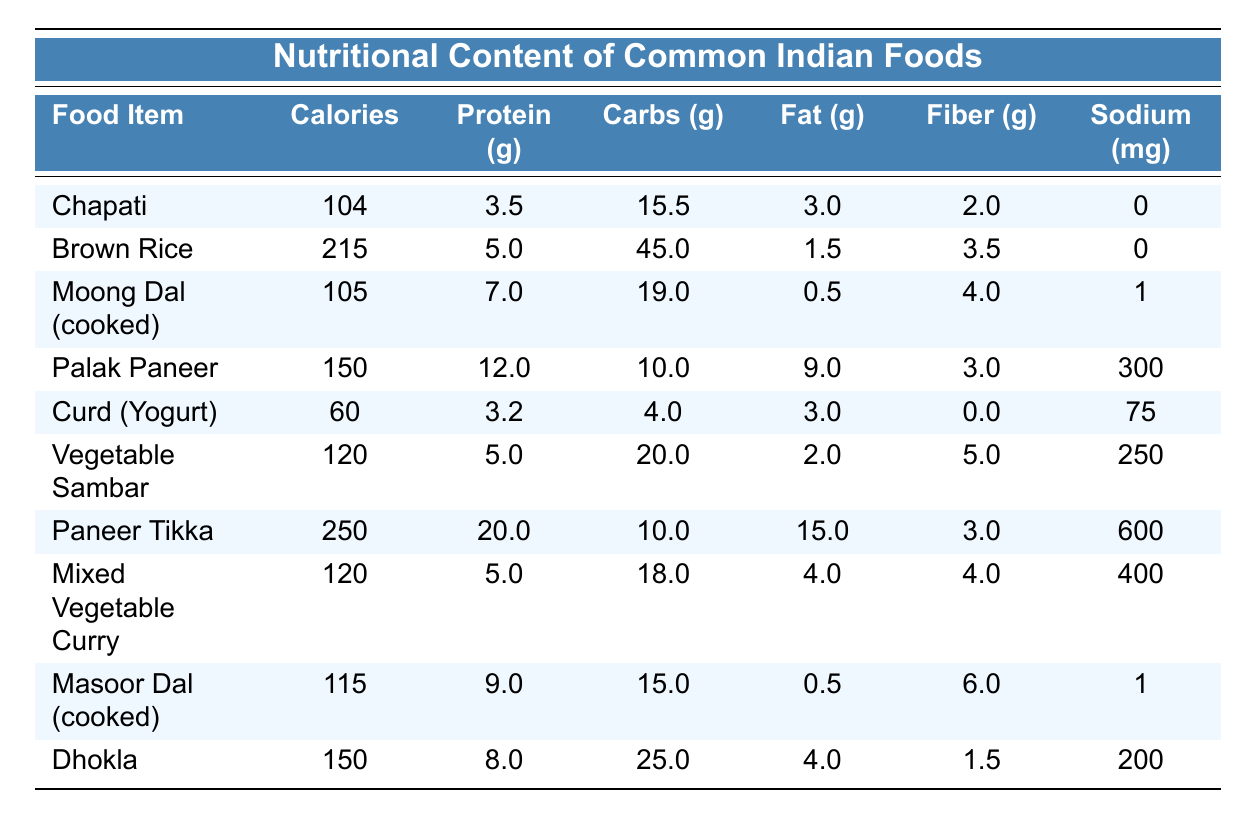What is the calorie content of Palak Paneer? The calorie content for Palak Paneer is mentioned in the table, specifically in the "Calories" column next to the food item. It shows that Palak Paneer has 150 calories.
Answer: 150 Which food item has the highest protein content? Looking at the "Protein (g)" column, the highest value is for Paneer Tikka, which has 20.0 grams of protein, compared to all other items listed.
Answer: Paneer Tikka Is the sodium content in Curd (Yogurt) more than that in Chapati? To answer this, we can compare the sodium content of both food items from the "Sodium (mg)" column. Curd (Yogurt) has 75 mg of sodium, while Chapati has 0 mg. Since 75 mg is greater than 0 mg, the statement is true.
Answer: Yes What is the total calorie content of Moong Dal and Masoor Dal combined? We need to add the calorie values of Moong Dal and Masoor Dal. Moong Dal has 105 calories, and Masoor Dal has 115 calories. Adding them together: 105 + 115 = 220.
Answer: 220 How much fiber is present in Vegetable Sambar compared to Dhokla? From the table, we see that Vegetable Sambar has 5.0 grams of fiber while Dhokla has 1.5 grams. Thus, Vegetable Sambar has more fiber, specifically 5.0 - 1.5 = 3.5 grams more.
Answer: Vegetable Sambar has more fiber What is the average fat content of Chapati, Brown Rice, and Curd (Yogurt)? To compute the average fat content, first, we identify the fat content per item: Chapati has 3.0 g, Brown Rice has 1.5 g, and Curd (Yogurt) has 3.0 g. We sum these values: 3.0 + 1.5 + 3.0 = 7.5 g, then divide by the number of items (3): 7.5 g / 3 = 2.5 g.
Answer: 2.5 Is there any food item with a sodium content of 100 mg or less? Checking the "Sodium (mg)" column, both Chapati and Brown Rice have a sodium value of 0 mg, and Curd (Yogurt) has 75 mg. Since both these values are 100 mg or less, yes, there are items with such sodium content.
Answer: Yes What food item has the lowest carbohydrate content? The carbohydrate values for food items are compared, and we see that Curd (Yogurt) has the lowest content at 4.0 grams.
Answer: Curd (Yogurt) How many grams of carbohydrates are there in the Mixed Vegetable Curry? The table lists Mixed Vegetable Curry under the "Carbohydrates (g)" column, and it shows that it has 18.0 grams of carbohydrates.
Answer: 18.0 